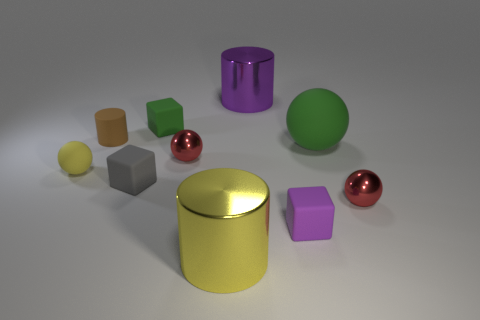What is the size of the purple thing that is the same shape as the large yellow thing?
Keep it short and to the point. Large. What size is the cube that is the same color as the large ball?
Your answer should be very brief. Small. Does the tiny purple object have the same material as the big object right of the small purple block?
Offer a terse response. Yes. What is the color of the small matte cylinder?
Your response must be concise. Brown. There is a ball that is made of the same material as the small yellow thing; what size is it?
Make the answer very short. Large. There is a red ball that is in front of the cube on the left side of the small green rubber object; what number of brown things are left of it?
Ensure brevity in your answer.  1. There is a large sphere; is its color the same as the small matte block that is behind the yellow ball?
Give a very brief answer. Yes. The thing that is the same color as the big rubber sphere is what shape?
Keep it short and to the point. Cube. What material is the green sphere in front of the big metal object behind the large cylinder that is left of the purple cylinder made of?
Your answer should be very brief. Rubber. Do the big object that is on the left side of the purple metallic thing and the small brown matte object have the same shape?
Provide a short and direct response. Yes. 